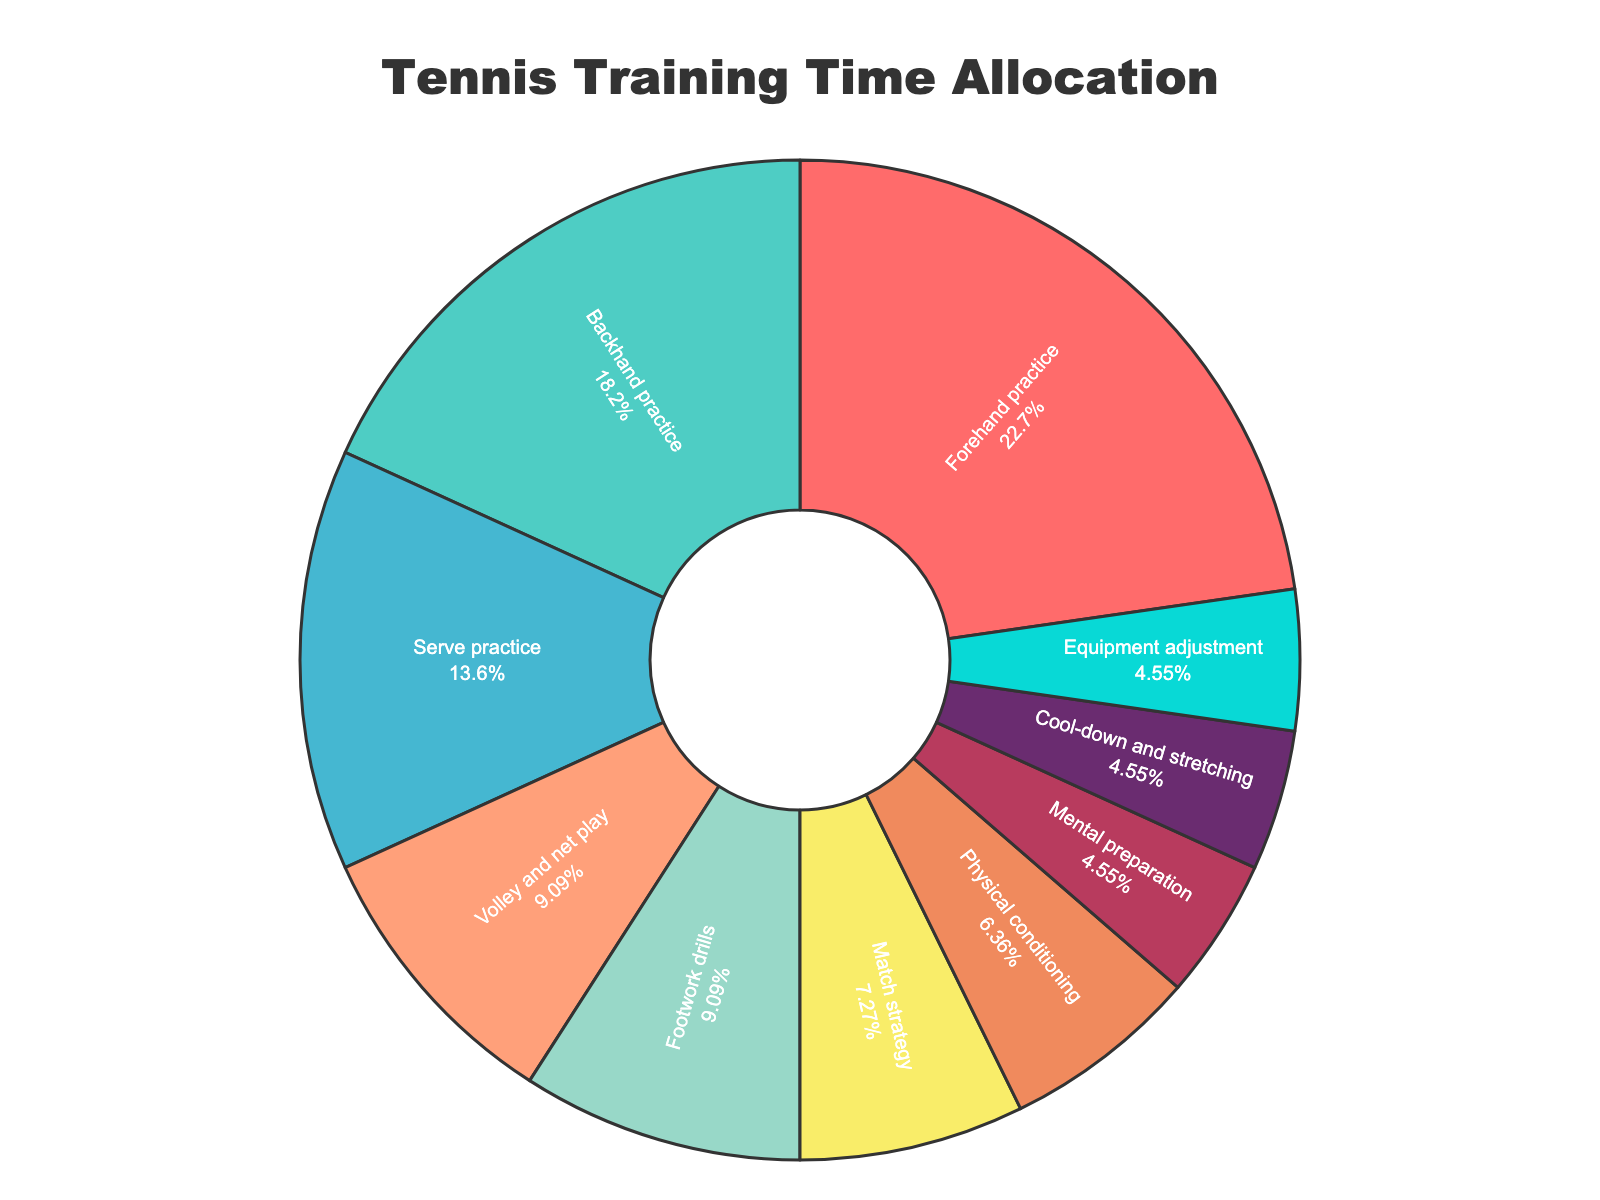What percentage of the total training time is allocated to serve practice? Look at the slice labeled "Serve practice" and note its percentage. The chart shows "Serve practice" occupying 13.6% of the total training time.
Answer: 13.6% Which activity has the smallest allocation of training time? Find the smallest slice in the pie chart. It is labeled "Mental preparation", "Cool-down and stretching", and "Equipment adjustment", each occupying an equal share of 4.5%.
Answer: Mental preparation, Cool-down and stretching, Equipment adjustment How much more training time is allocated to forehand practice compared to backhand practice? Forehand practice is allocated 25 minutes and backhand practice is allocated 20 minutes. Subtract to find the difference: 25 - 20 = 5 minutes.
Answer: 5 minutes What is the combined percentage of the total training time for footwork drills and physical conditioning? Find the percentages for footwork drills and physical conditioning: 9.1% and 6.4% respectively. Add them together: 9.1% + 6.4% = 15.5%.
Answer: 15.5% Which two activities together make up the second-largest combined total training time after forehand practice? Forehand practice is 25 minutes. The next largest combined total is serve practice (15 minutes) and backhand practice (20 minutes): 15 + 20 = 35 minutes.
Answer: Serve practice and backhand practice What percentage of the total training time is spent on activities related to gameplay strategy (match strategy and mental preparation)? Find the percentages for match strategy and mental preparation: 7.3% and 4.5% respectively. Add them together: 7.3% + 4.5% = 11.8%.
Answer: 11.8% What skill occupies the largest slice in the pie chart? Identify the largest slice. The chart shows "Forehand practice" occupies the largest slice with 22.7%.
Answer: Forehand practice What is the total number of minutes allocated to cool-down and stretching, and equipment adjustment combined? Both cool-down and stretching, and equipment adjustment are allocated 5 minutes each. Add them together: 5 + 5 = 10 minutes.
Answer: 10 minutes 